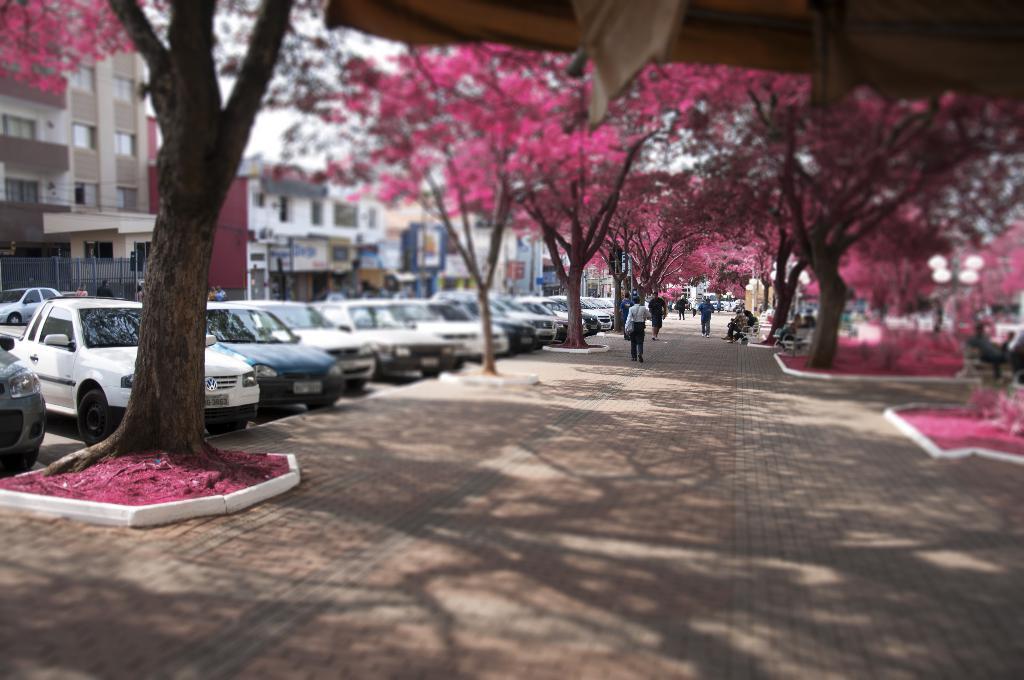How would you summarize this image in a sentence or two? In this image we can see many cars. There are many buildings and houses in the image. There are many trees in the image. There are many flowers to the trees. There is a walkway in the image. There are many people in the image. 